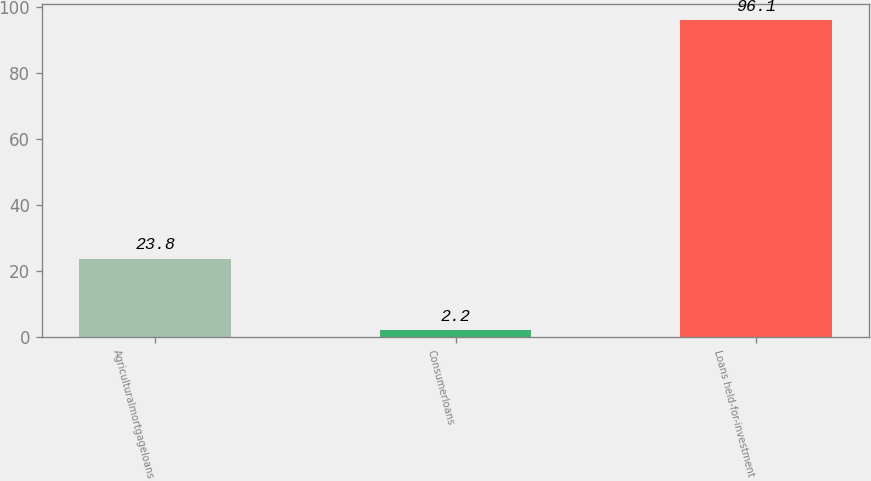<chart> <loc_0><loc_0><loc_500><loc_500><bar_chart><fcel>Agriculturalmortgageloans<fcel>Consumerloans<fcel>Loans held-for-investment<nl><fcel>23.8<fcel>2.2<fcel>96.1<nl></chart> 